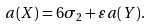<formula> <loc_0><loc_0><loc_500><loc_500>a ( X ) = 6 \sigma _ { 2 } + \varepsilon a ( Y ) .</formula> 